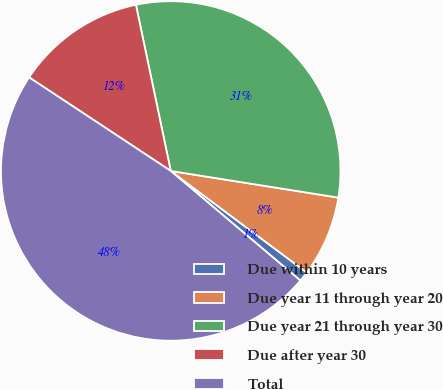<chart> <loc_0><loc_0><loc_500><loc_500><pie_chart><fcel>Due within 10 years<fcel>Due year 11 through year 20<fcel>Due year 21 through year 30<fcel>Due after year 30<fcel>Total<nl><fcel>0.96%<fcel>7.7%<fcel>30.8%<fcel>12.42%<fcel>48.12%<nl></chart> 